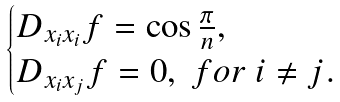<formula> <loc_0><loc_0><loc_500><loc_500>\begin{cases} D _ { x _ { i } x _ { i } } f = \cos \frac { \pi } { n } , \\ D _ { x _ { i } x _ { j } } f = 0 , \ f o r \ i \neq j . \end{cases}</formula> 